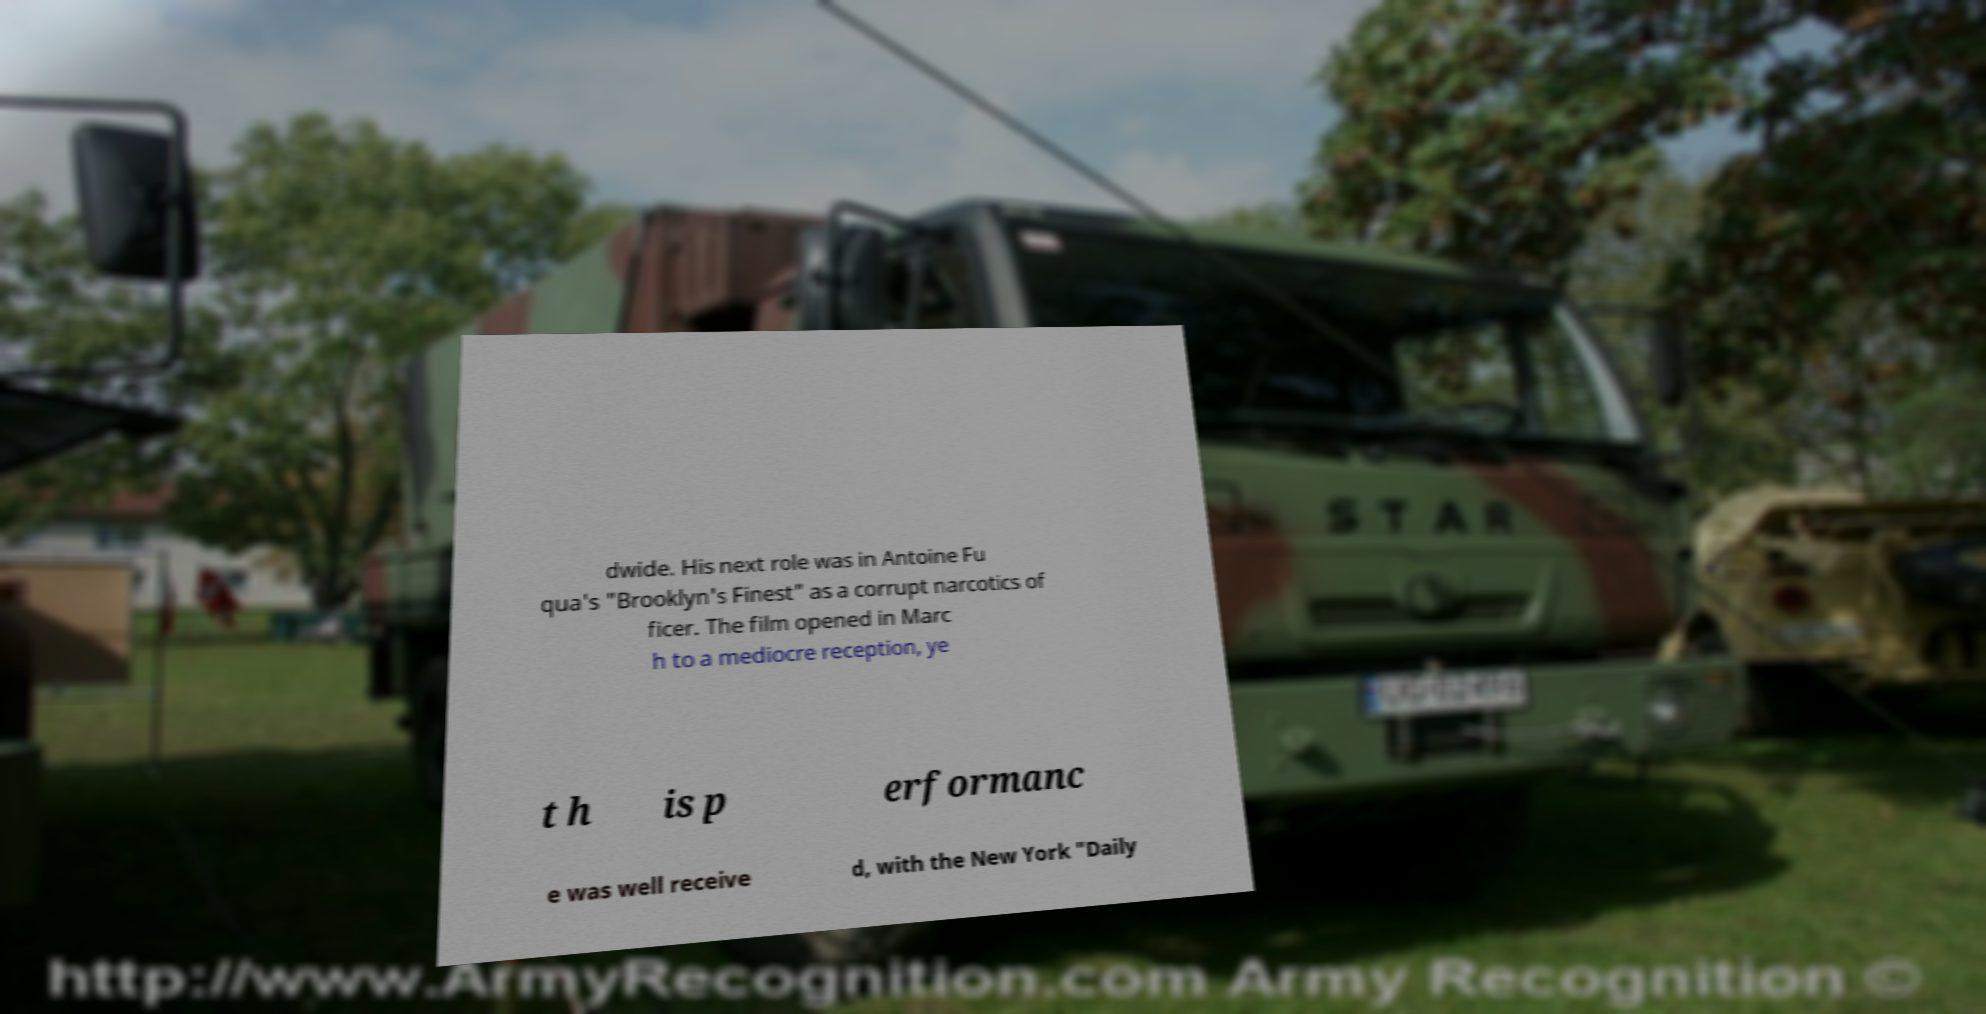Please read and relay the text visible in this image. What does it say? dwide. His next role was in Antoine Fu qua's "Brooklyn's Finest" as a corrupt narcotics of ficer. The film opened in Marc h to a mediocre reception, ye t h is p erformanc e was well receive d, with the New York "Daily 